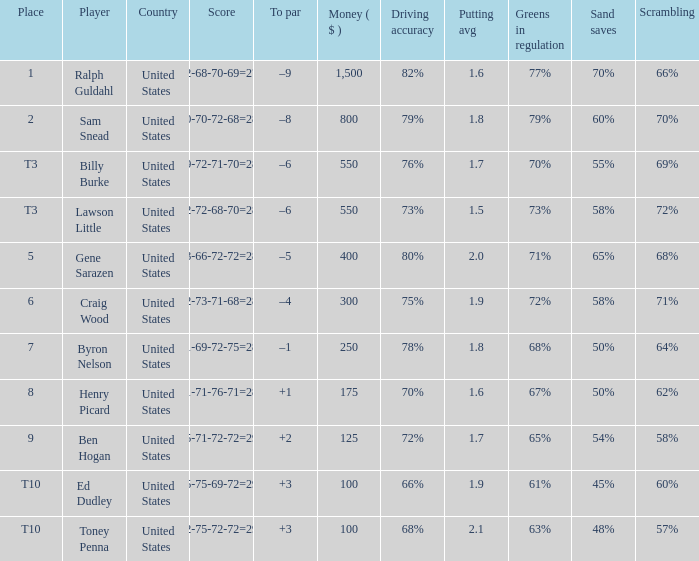Which to par has a prize less than $800? –8. 